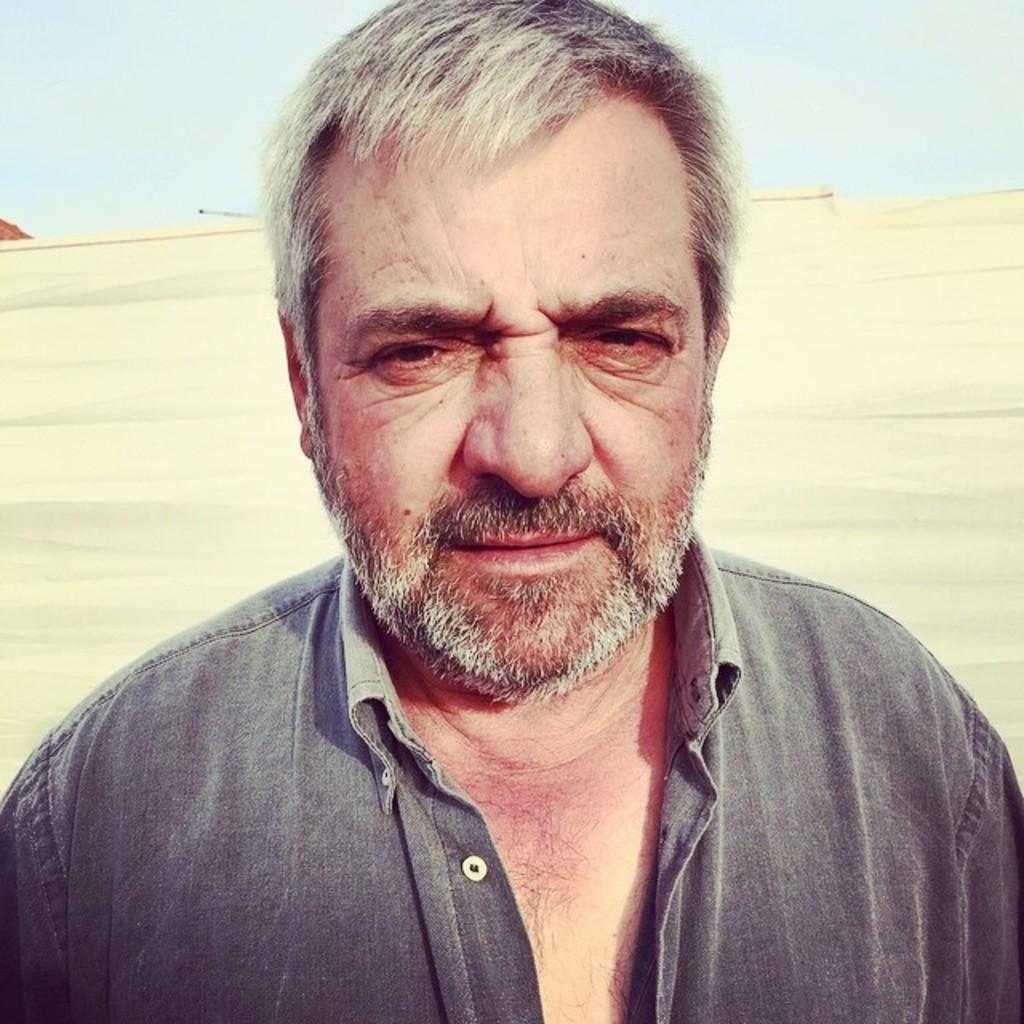Where was the image taken? The image is taken outdoors. What can be seen in the background of the image? There is a ground visible in the background of the image. What is visible at the top of the image? There is a sky with clouds at the top of the image. Who is the main subject in the image? There is a man in the middle of the image. What month is the man celebrating in the image? The image does not provide any information about the month or any celebration. 